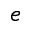Convert formula to latex. <formula><loc_0><loc_0><loc_500><loc_500>^ { e }</formula> 